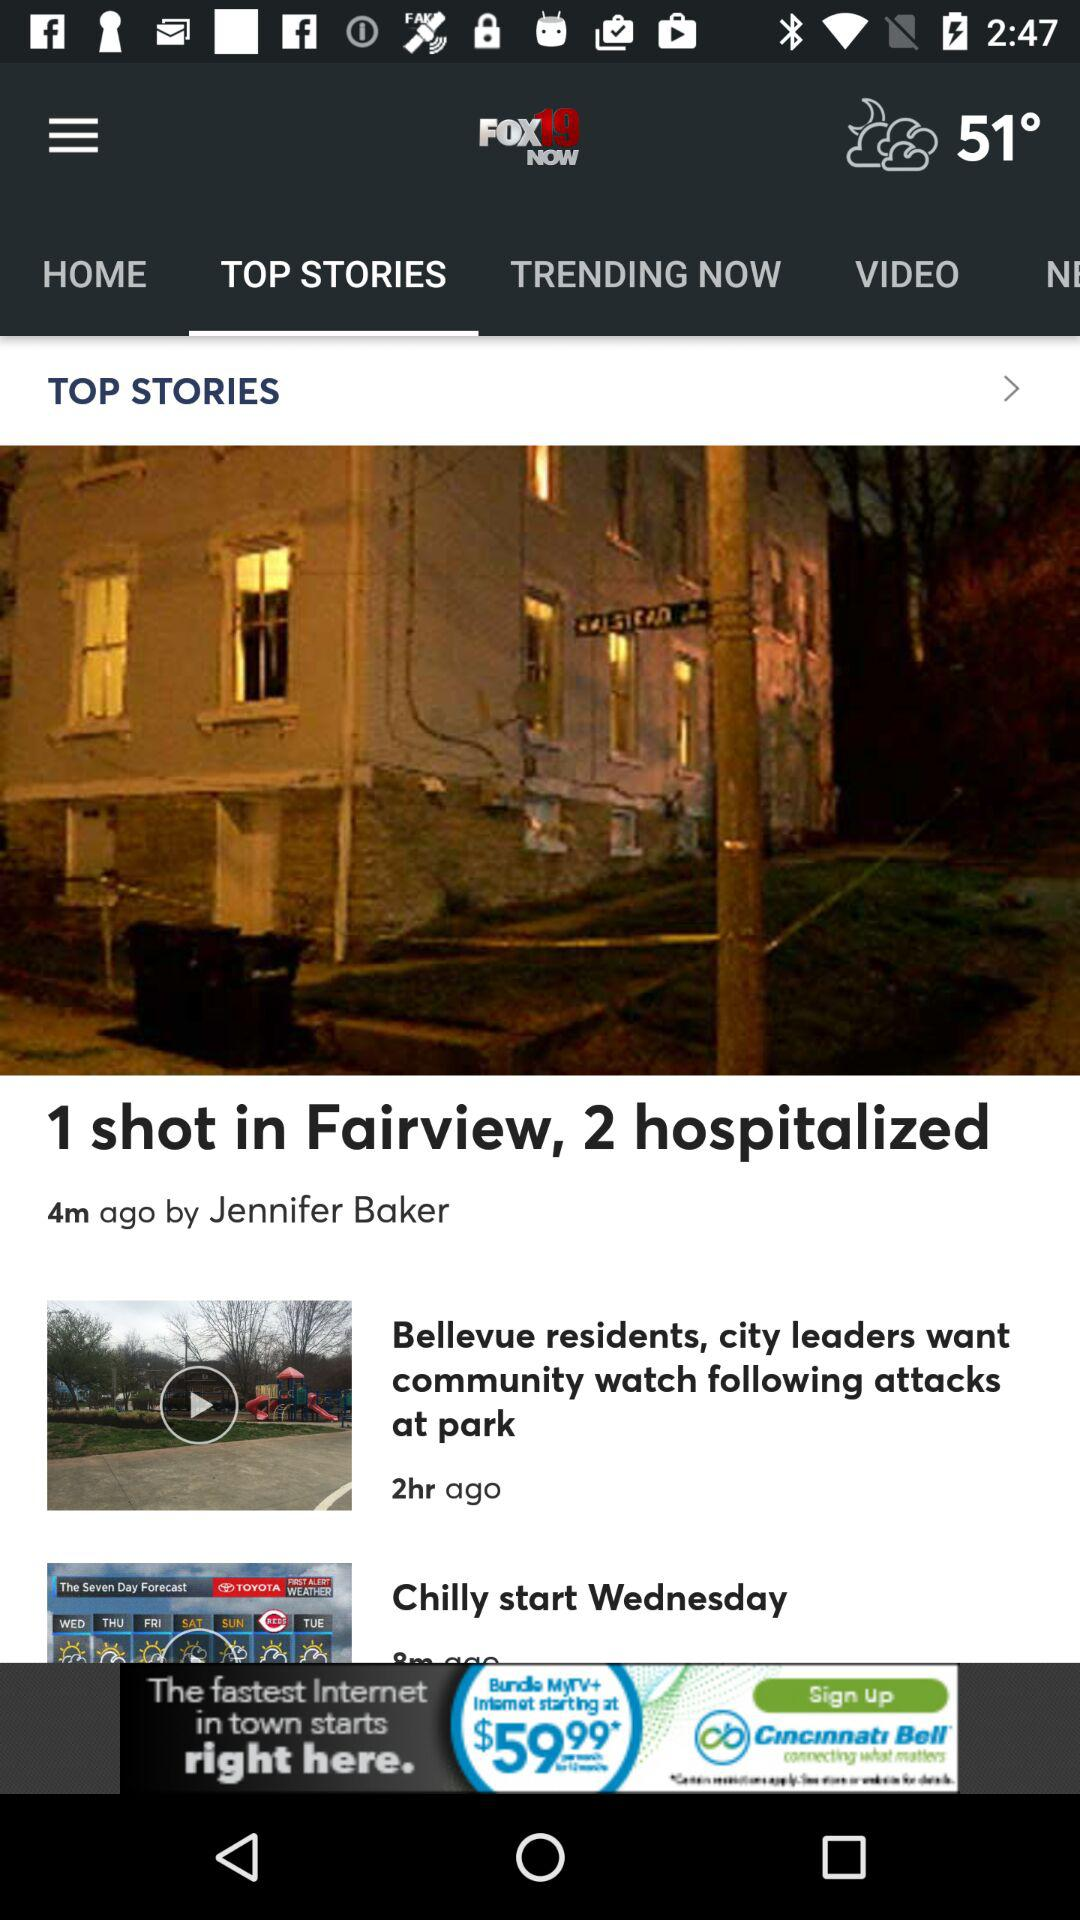By whom is the post "1 shot in Fairview" posted? The post "1 shot in Fairview" was posted by Jennifer Baker. 